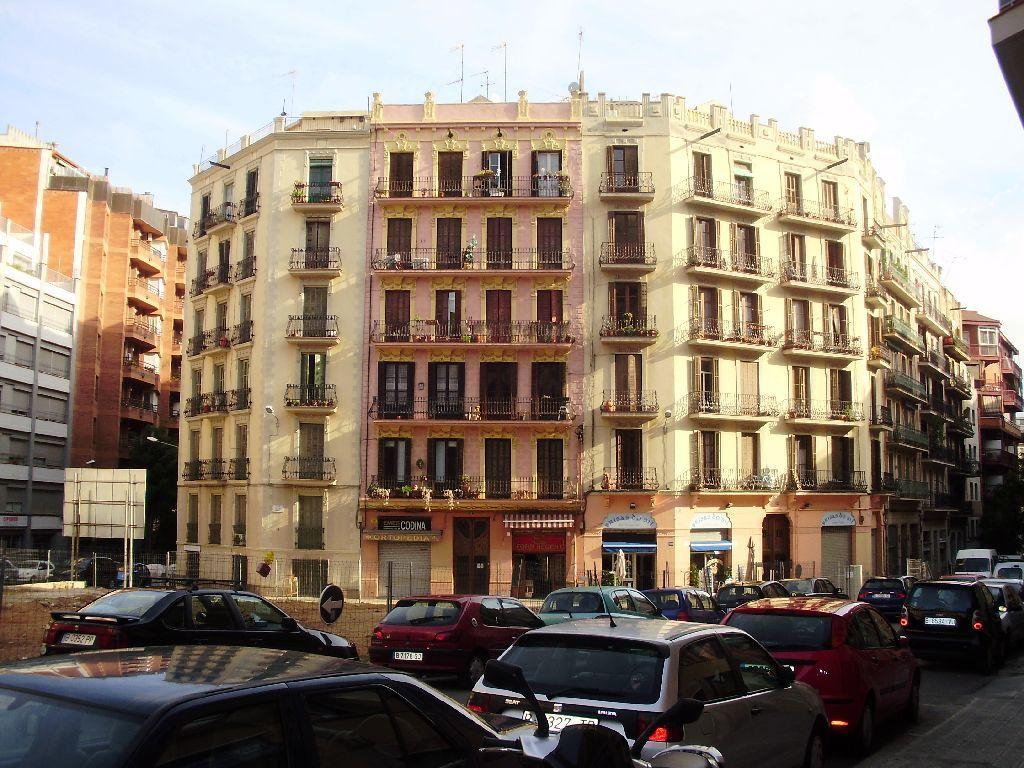What is happening in the image? There are cars on a road in the image. What can be seen in the distance behind the cars? There are buildings and a board in the background of the image. What is visible above the buildings and the board? The sky is visible in the image. What advice does the advertisement on the board give to the user's uncle? There is no advertisement or uncle present in the image, so it is not possible to answer that question. 